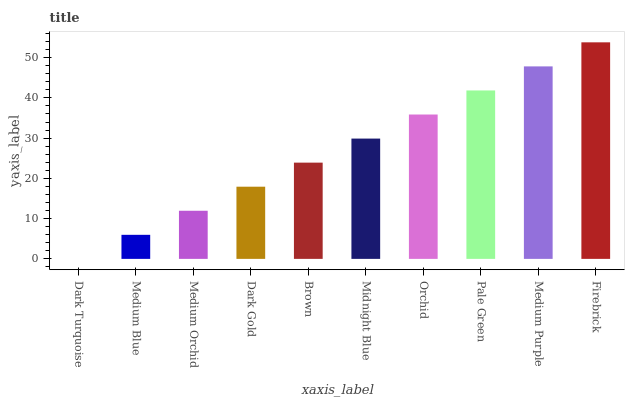Is Medium Blue the minimum?
Answer yes or no. No. Is Medium Blue the maximum?
Answer yes or no. No. Is Medium Blue greater than Dark Turquoise?
Answer yes or no. Yes. Is Dark Turquoise less than Medium Blue?
Answer yes or no. Yes. Is Dark Turquoise greater than Medium Blue?
Answer yes or no. No. Is Medium Blue less than Dark Turquoise?
Answer yes or no. No. Is Midnight Blue the high median?
Answer yes or no. Yes. Is Brown the low median?
Answer yes or no. Yes. Is Brown the high median?
Answer yes or no. No. Is Orchid the low median?
Answer yes or no. No. 